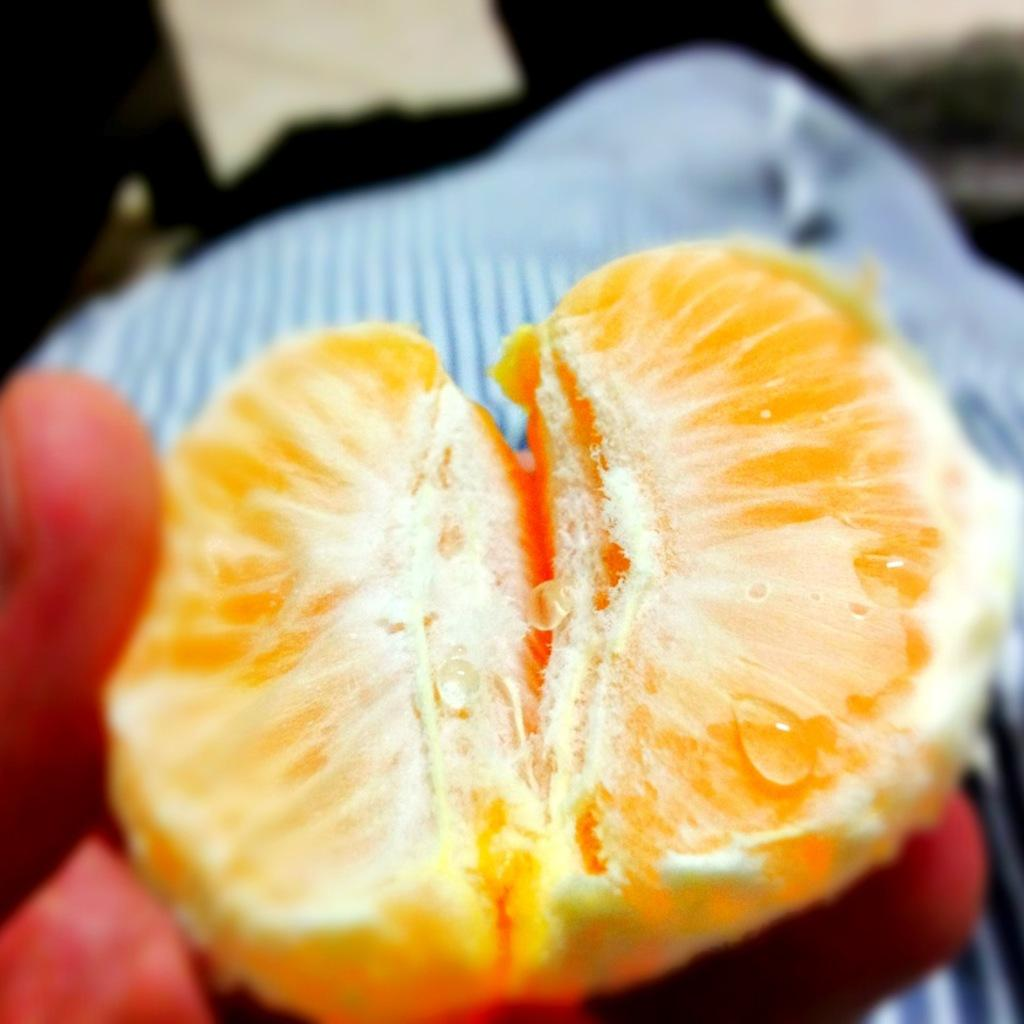What is the main subject of the image? There is a person in the image. What is the person doing in the image? The person is holding the sides of an orange. What type of furniture is present in the image? There is a bed in the image. Can you describe any other objects visible in the image? There are other objects visible in the image, but their specific details are not mentioned in the provided facts. How does the person pull the giraffe in the image? There is no giraffe present in the image, so the person cannot pull a giraffe. 